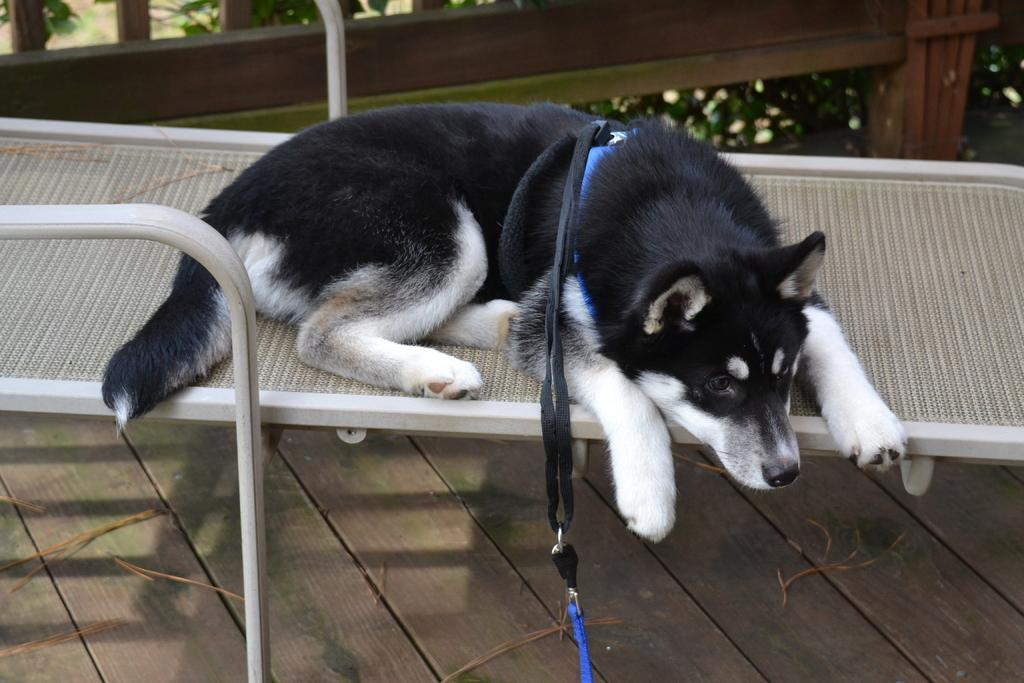What type of seating is visible in the image? There is a bench in the image. What is the bench resting on? The bench is on a wooden surface. What animal is sitting on the bench? There is a dog on the bench. What can be seen in the background of the image? There are wooden planks and plants with flowers in the background of the image. What type of guitar is the dog playing in the image? There is no guitar present in the image; it features a dog sitting on a bench. 